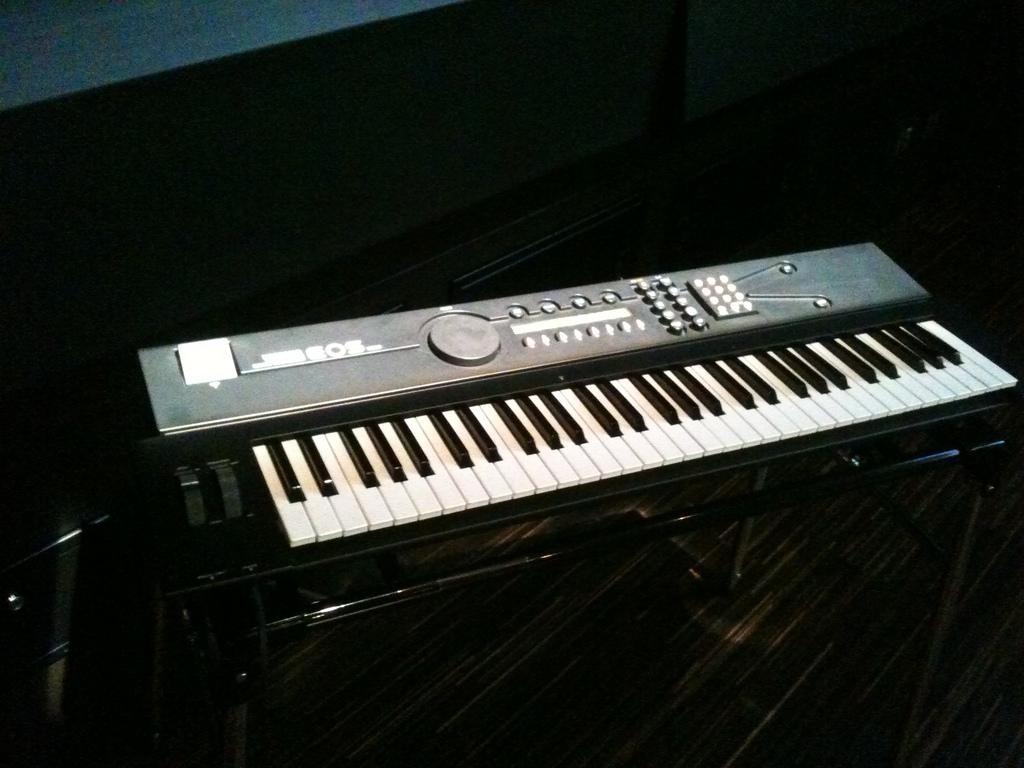What musical instrument is present in the image? There is a piano in the image. How is the piano positioned in the image? The piano is on a stand. What part of the room can be seen in the image? The floor is visible in the image. What type of food is the piano producing in the image? The piano is not a food-producing object; it is a musical instrument. 